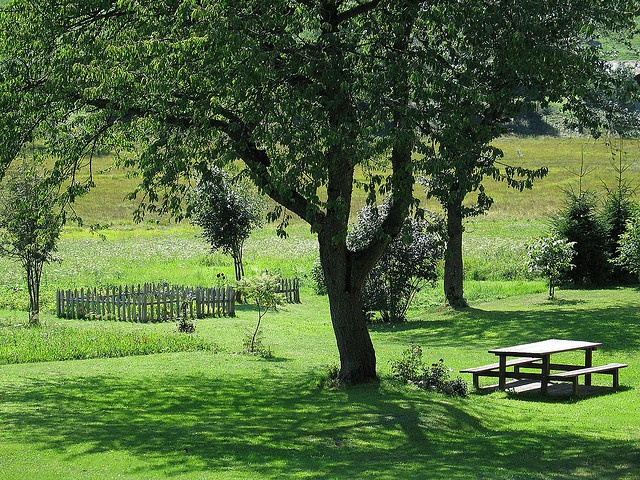Describe the objects in this image and their specific colors. I can see a bench in green, black, white, lightgreen, and darkgreen tones in this image. 